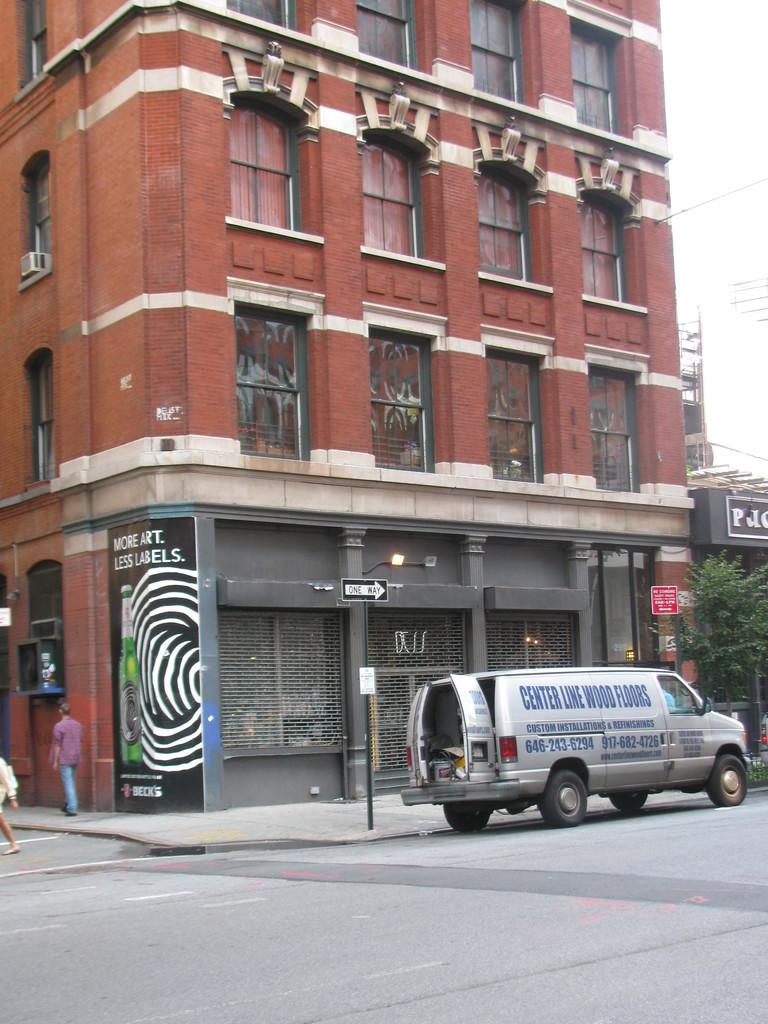<image>
Summarize the visual content of the image. A van from Center Line Wood Floors is parked outside of a brick building. 